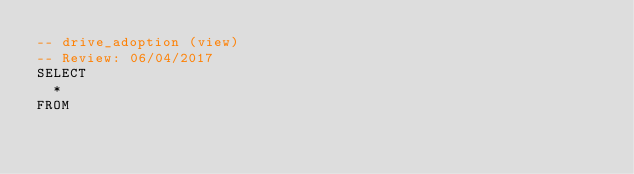Convert code to text. <code><loc_0><loc_0><loc_500><loc_500><_SQL_>-- drive_adoption (view)
-- Review: 06/04/2017
SELECT
  *
FROM</code> 